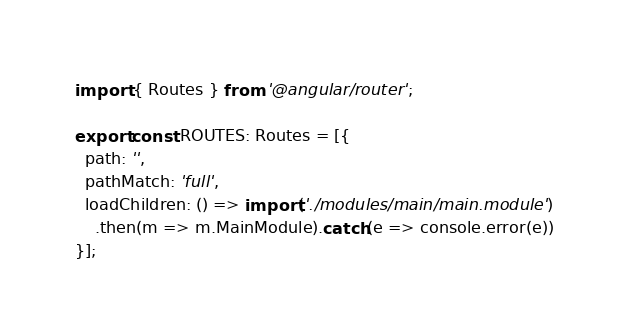Convert code to text. <code><loc_0><loc_0><loc_500><loc_500><_TypeScript_>import { Routes } from '@angular/router';

export const ROUTES: Routes = [{
  path: '',
  pathMatch: 'full',
  loadChildren: () => import('./modules/main/main.module')
    .then(m => m.MainModule).catch(e => console.error(e))
}];
</code> 